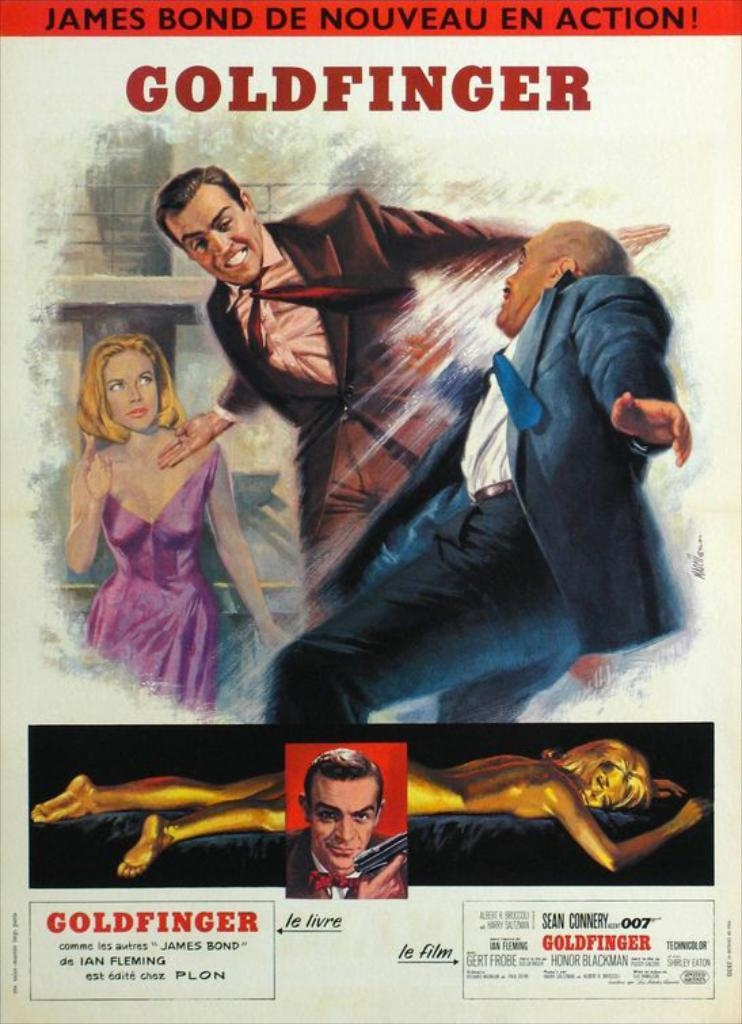<image>
Give a short and clear explanation of the subsequent image. A French poster for the James Bond movie Goldfinger 